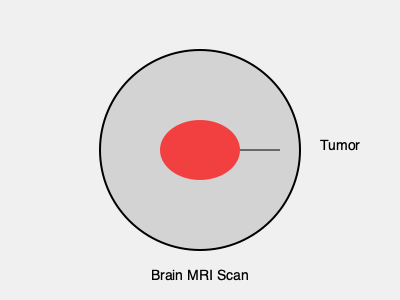In the context of brain MRI segmentation for tumor volume measurement, which image processing technique is most effective for accurately delineating tumor boundaries while minimizing false positives in surrounding healthy tissue? To accurately segment brain MRI scans and measure tumor volumes, several image processing techniques can be employed. The most effective approach typically involves a combination of methods:

1. Preprocessing:
   - Noise reduction using Gaussian or median filters
   - Intensity normalization to account for MRI machine variations

2. Initial Segmentation:
   - Thresholding to separate potential tumor regions from background
   - Edge detection to identify boundaries between different tissue types

3. Advanced Segmentation:
   - Region growing to expand from seed points within the tumor
   - Active contours (snakes) to refine tumor boundaries

4. Machine Learning Approaches:
   - Convolutional Neural Networks (CNNs) for automated feature extraction
   - U-Net architecture, specifically designed for biomedical image segmentation

5. Post-processing:
   - Morphological operations to refine segmentation results
   - Connected component analysis to remove small, isolated regions

Among these techniques, the most effective for accurately delineating tumor boundaries while minimizing false positives is the U-Net architecture. U-Net, a type of CNN, has shown superior performance in medical image segmentation tasks for several reasons:

- It can learn to differentiate subtle texture and intensity differences between tumor and healthy tissue
- The architecture allows for precise localization through skip connections between encoding and decoding paths
- It can be trained on relatively small datasets, which is often the case in medical imaging
- U-Net can incorporate both local and global context, essential for understanding complex anatomical structures

U-Net's effectiveness has been demonstrated in numerous studies, consistently outperforming traditional image processing techniques in terms of accuracy and robustness when segmenting brain tumors from MRI scans.
Answer: U-Net architecture 